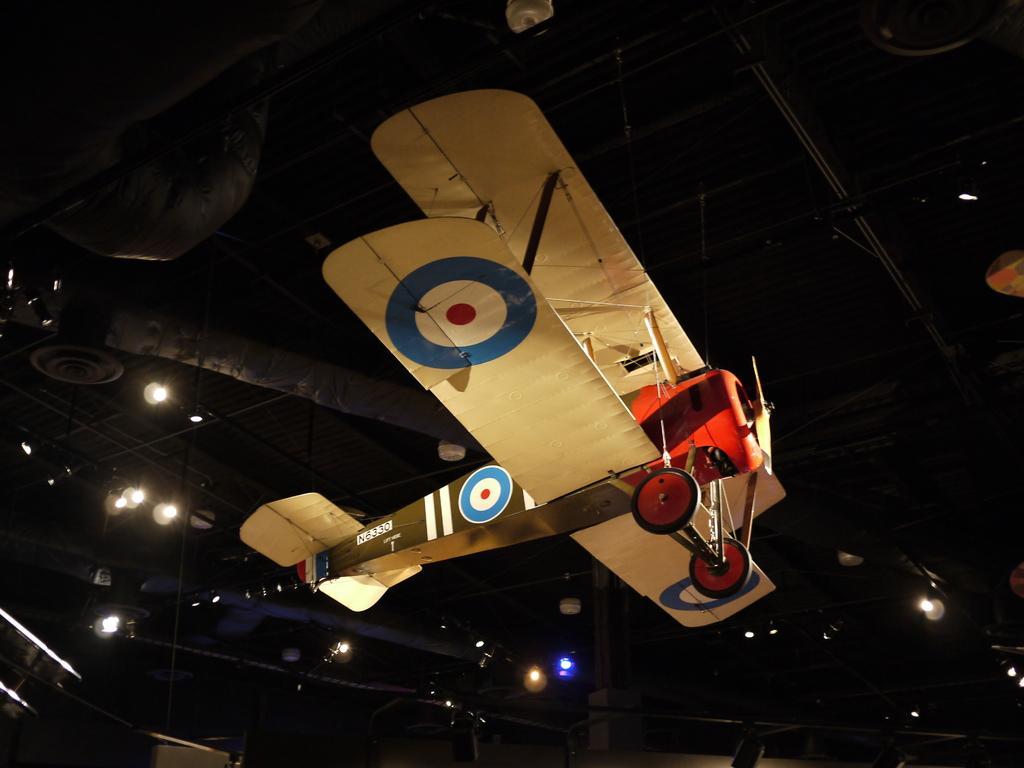Can you describe this image briefly? In this picture, we can see a toy aircraft hanging and we can see the roof with some light, rods and some objects attached to it. 